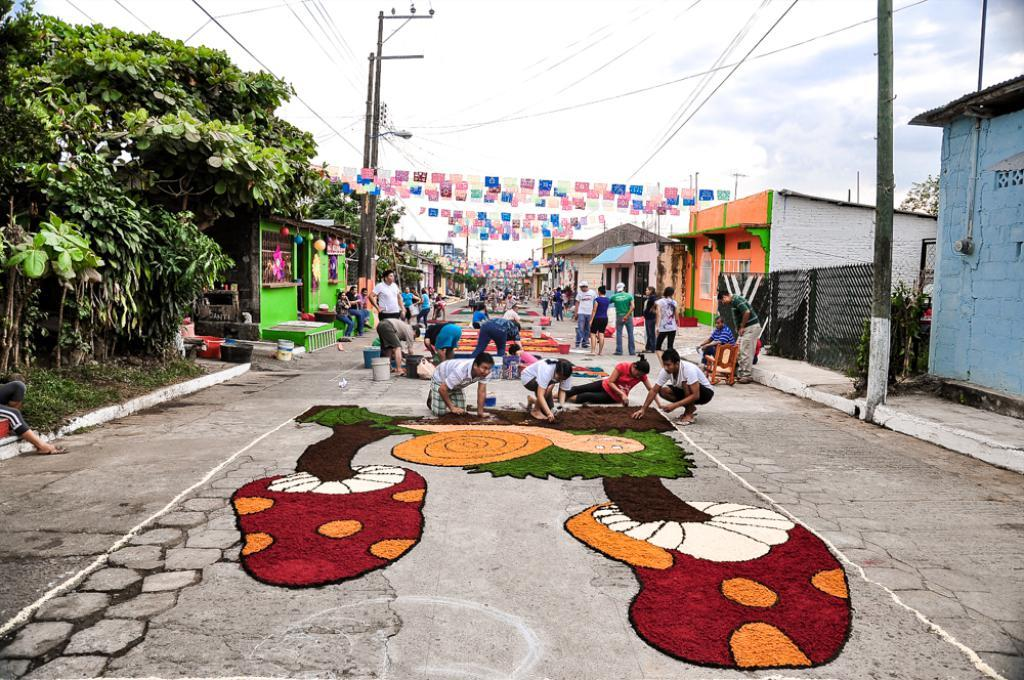What is the main subject of the image? The image depicts a road. What are the people doing on the road? People are making paintings on the road. What can be seen on the left side of the road? There are trees on the left side of the road. What type of structures are present on either side of the road? There are houses on either side of the road. What type of quill is being used by the people to make paintings on the road? There is no mention of a quill being used in the image; people are likely using paintbrushes or other painting tools. How many ducks are visible on the road in the image? There are no ducks present in the image; the focus is on the people making paintings and the surrounding environment. 